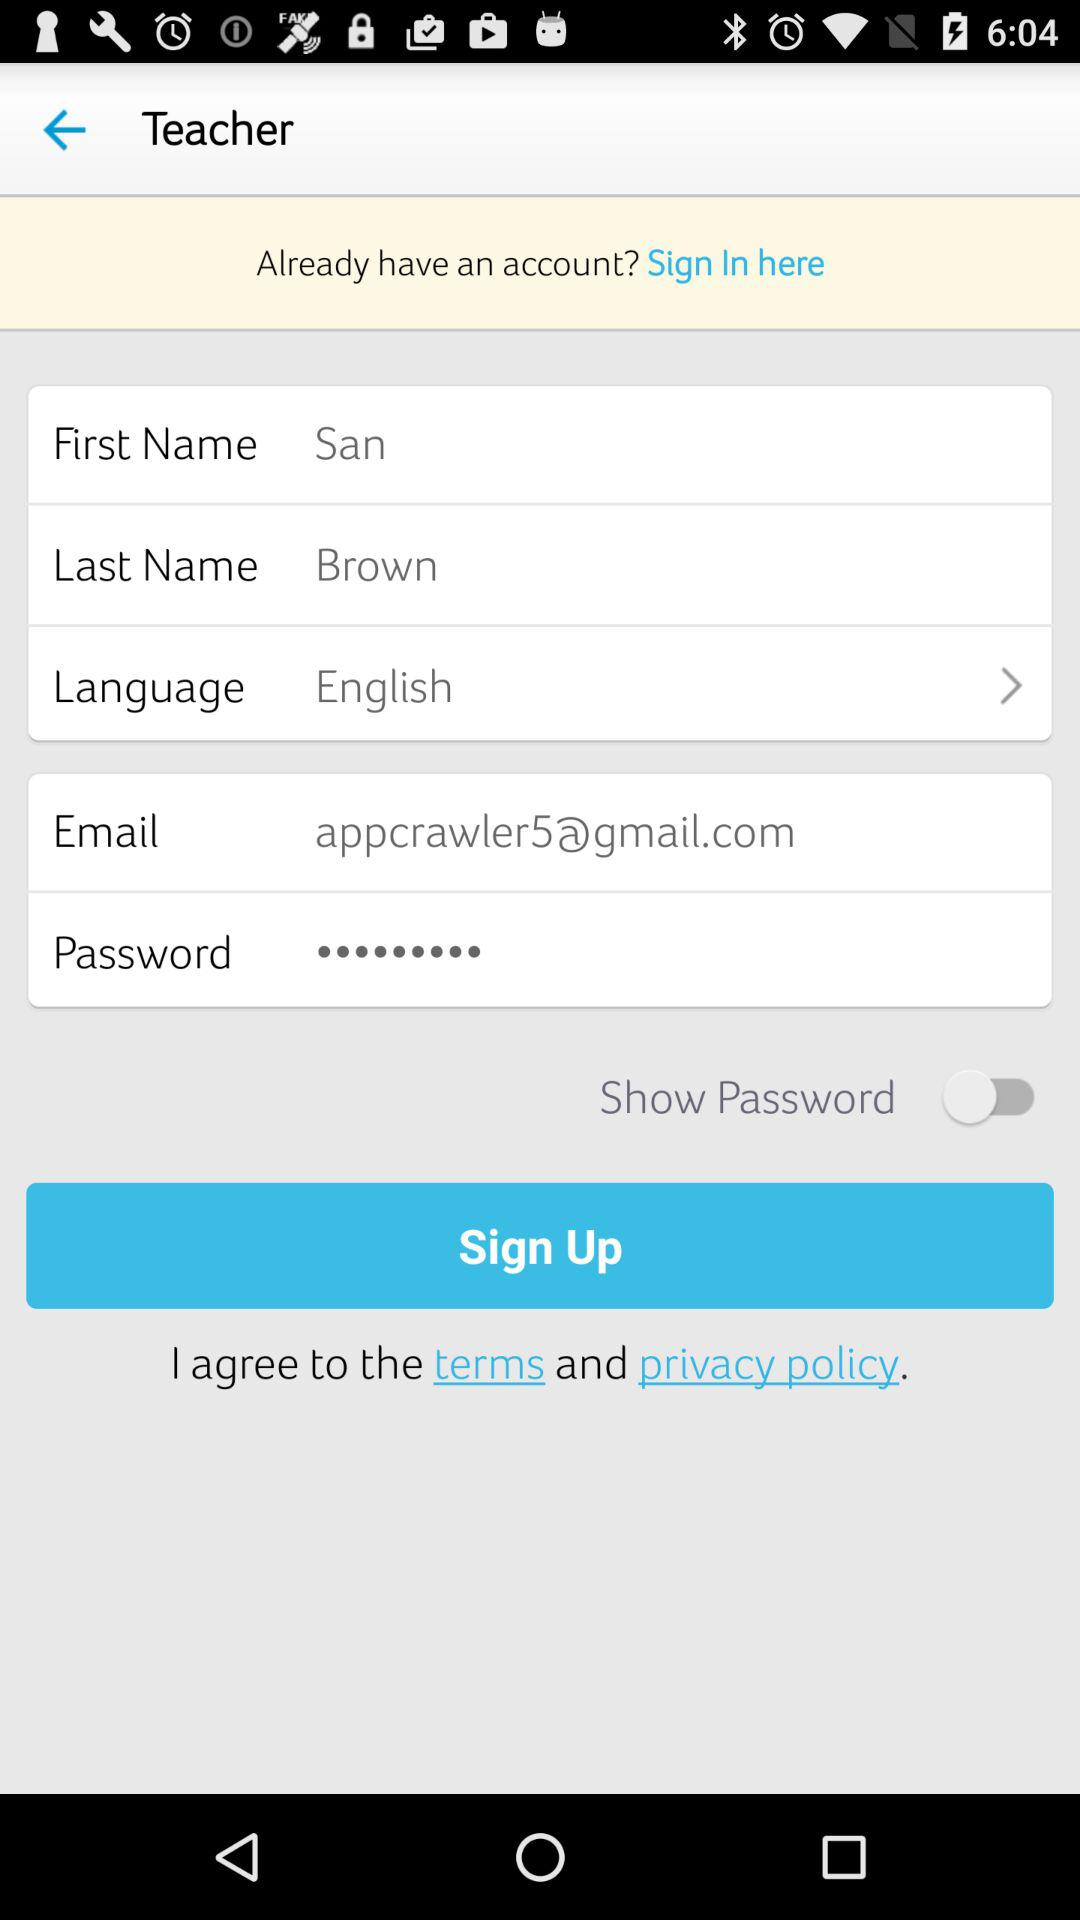Which language has been selected? The language that has been selected is English. 